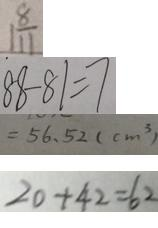<formula> <loc_0><loc_0><loc_500><loc_500>1 \frac { 8 } { 1 1 } 
 8 8 - 8 1 = 7 
 = 5 6 . 5 2 ( c m ^ { 3 } ) 
 2 0 + 4 2 = 6 2</formula> 